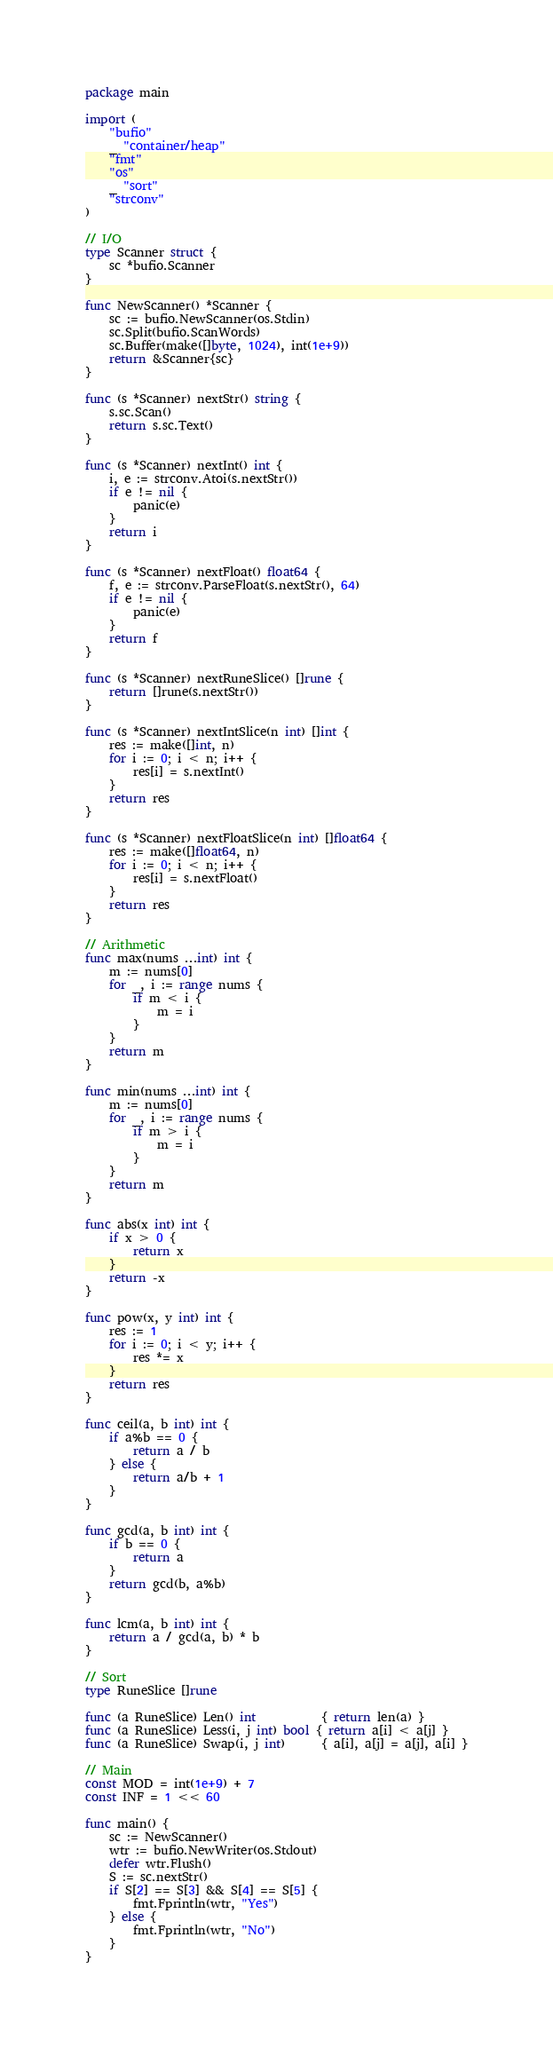Convert code to text. <code><loc_0><loc_0><loc_500><loc_500><_Go_>package main

import (
	"bufio"
	_ "container/heap"
	"fmt"
	"os"
	_ "sort"
	"strconv"
)

// I/O
type Scanner struct {
	sc *bufio.Scanner
}

func NewScanner() *Scanner {
	sc := bufio.NewScanner(os.Stdin)
	sc.Split(bufio.ScanWords)
	sc.Buffer(make([]byte, 1024), int(1e+9))
	return &Scanner{sc}
}

func (s *Scanner) nextStr() string {
	s.sc.Scan()
	return s.sc.Text()
}

func (s *Scanner) nextInt() int {
	i, e := strconv.Atoi(s.nextStr())
	if e != nil {
		panic(e)
	}
	return i
}

func (s *Scanner) nextFloat() float64 {
	f, e := strconv.ParseFloat(s.nextStr(), 64)
	if e != nil {
		panic(e)
	}
	return f
}

func (s *Scanner) nextRuneSlice() []rune {
	return []rune(s.nextStr())
}

func (s *Scanner) nextIntSlice(n int) []int {
	res := make([]int, n)
	for i := 0; i < n; i++ {
		res[i] = s.nextInt()
	}
	return res
}

func (s *Scanner) nextFloatSlice(n int) []float64 {
	res := make([]float64, n)
	for i := 0; i < n; i++ {
		res[i] = s.nextFloat()
	}
	return res
}

// Arithmetic
func max(nums ...int) int {
	m := nums[0]
	for _, i := range nums {
		if m < i {
			m = i
		}
	}
	return m
}

func min(nums ...int) int {
	m := nums[0]
	for _, i := range nums {
		if m > i {
			m = i
		}
	}
	return m
}

func abs(x int) int {
	if x > 0 {
		return x
	}
	return -x
}

func pow(x, y int) int {
	res := 1
	for i := 0; i < y; i++ {
		res *= x
	}
	return res
}

func ceil(a, b int) int {
	if a%b == 0 {
		return a / b
	} else {
		return a/b + 1
	}
}

func gcd(a, b int) int {
	if b == 0 {
		return a
	}
	return gcd(b, a%b)
}

func lcm(a, b int) int {
	return a / gcd(a, b) * b
}

// Sort
type RuneSlice []rune

func (a RuneSlice) Len() int           { return len(a) }
func (a RuneSlice) Less(i, j int) bool { return a[i] < a[j] }
func (a RuneSlice) Swap(i, j int)      { a[i], a[j] = a[j], a[i] }

// Main
const MOD = int(1e+9) + 7
const INF = 1 << 60

func main() {
	sc := NewScanner()
	wtr := bufio.NewWriter(os.Stdout)
	defer wtr.Flush()
	S := sc.nextStr()
	if S[2] == S[3] && S[4] == S[5] {
		fmt.Fprintln(wtr, "Yes")
	} else {
		fmt.Fprintln(wtr, "No")
	}
}
</code> 